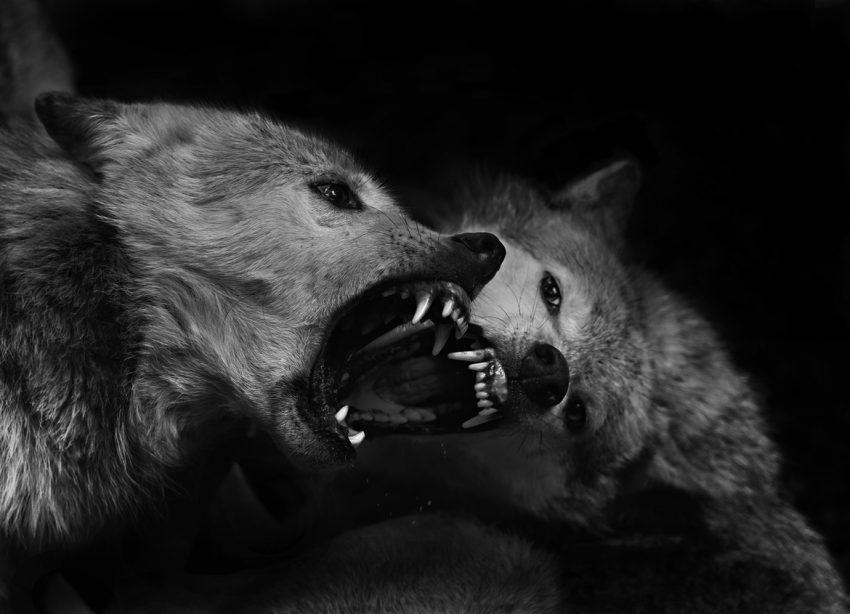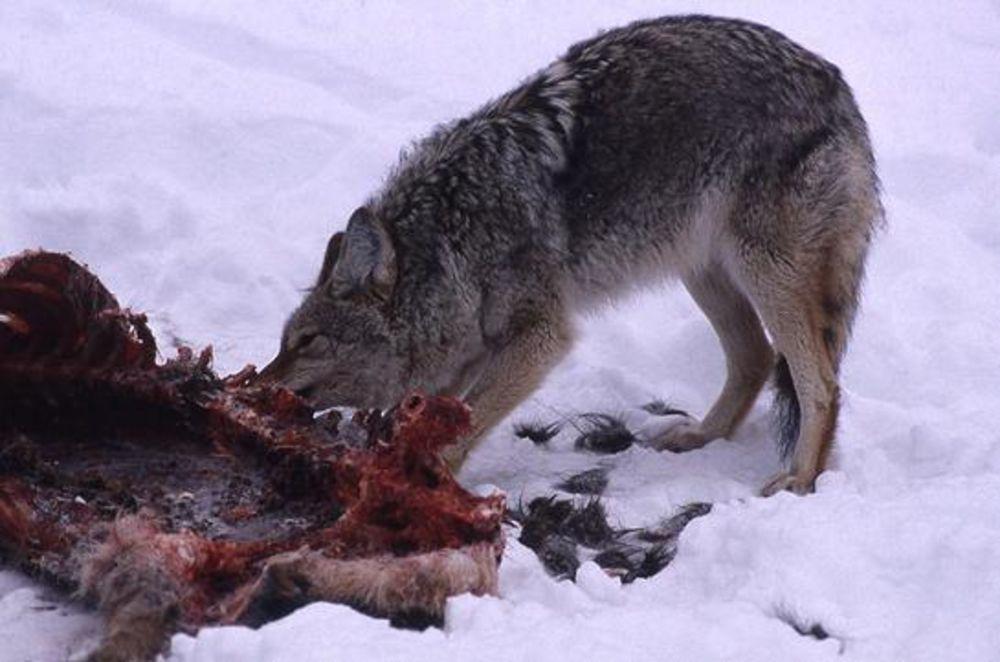The first image is the image on the left, the second image is the image on the right. For the images shown, is this caption "There are three wolves." true? Answer yes or no. Yes. The first image is the image on the left, the second image is the image on the right. Considering the images on both sides, is "The combined images contain three live animals, two animals have wide-open mouths, and at least two of the animals are wolves." valid? Answer yes or no. Yes. 